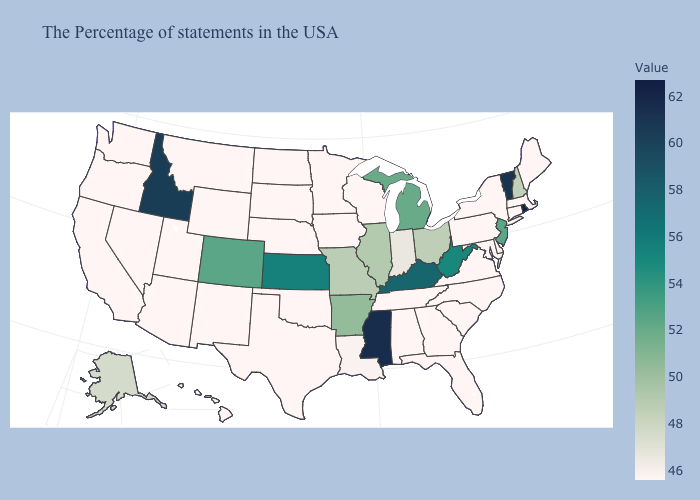Which states have the lowest value in the MidWest?
Write a very short answer. Wisconsin, Minnesota, Iowa, Nebraska, South Dakota, North Dakota. Which states have the lowest value in the USA?
Concise answer only. Maine, Massachusetts, Connecticut, New York, Delaware, Maryland, Pennsylvania, Virginia, North Carolina, South Carolina, Florida, Georgia, Alabama, Tennessee, Wisconsin, Minnesota, Iowa, Nebraska, Oklahoma, Texas, South Dakota, North Dakota, Wyoming, New Mexico, Utah, Montana, Arizona, Nevada, California, Washington, Oregon, Hawaii. Among the states that border Pennsylvania , which have the highest value?
Short answer required. West Virginia. Does Massachusetts have a higher value than Vermont?
Short answer required. No. Among the states that border Vermont , which have the lowest value?
Write a very short answer. Massachusetts, New York. Among the states that border California , which have the lowest value?
Answer briefly. Arizona, Nevada, Oregon. 